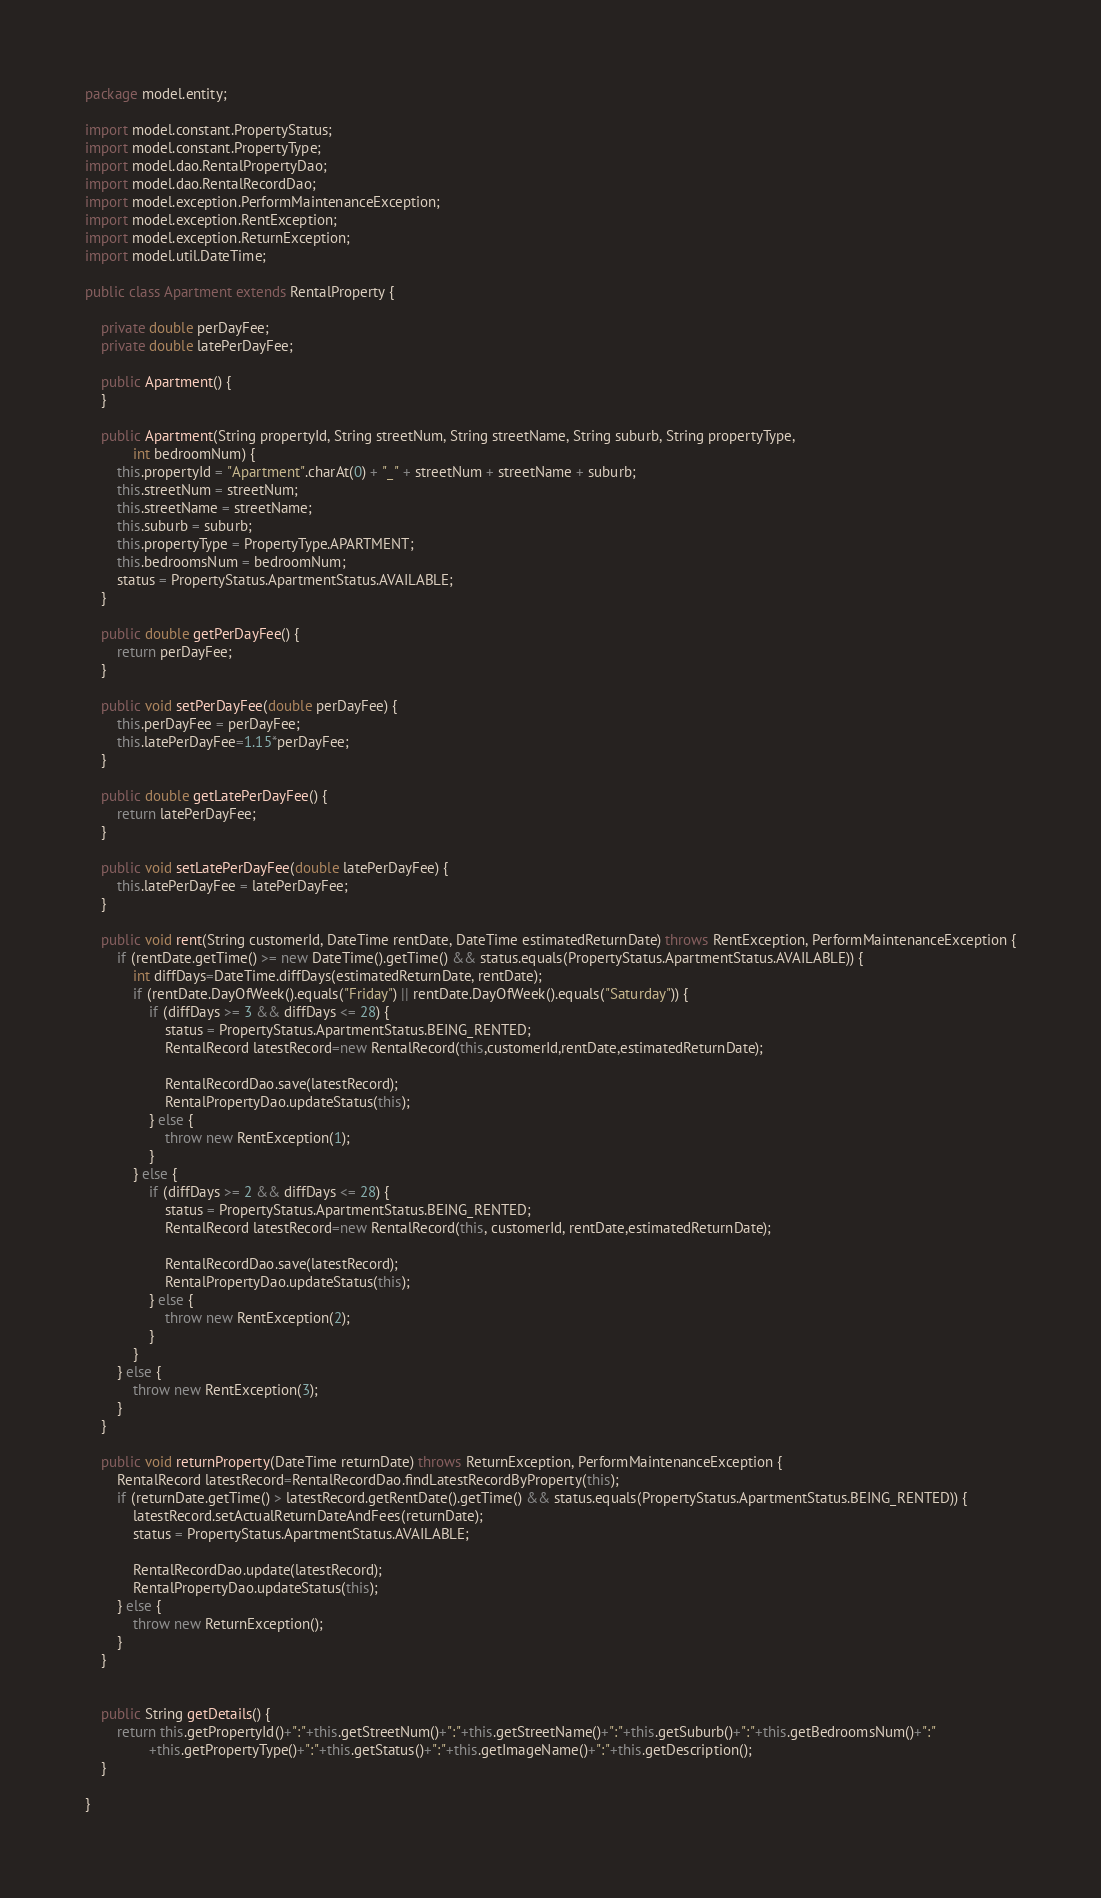Convert code to text. <code><loc_0><loc_0><loc_500><loc_500><_Java_>package model.entity;

import model.constant.PropertyStatus;
import model.constant.PropertyType;
import model.dao.RentalPropertyDao;
import model.dao.RentalRecordDao;
import model.exception.PerformMaintenanceException;
import model.exception.RentException;
import model.exception.ReturnException;
import model.util.DateTime;

public class Apartment extends RentalProperty {

	private double perDayFee;
	private double latePerDayFee;
	
	public Apartment() {
	}

	public Apartment(String propertyId, String streetNum, String streetName, String suburb, String propertyType,
			int bedroomNum) {
		this.propertyId = "Apartment".charAt(0) + "_" + streetNum + streetName + suburb;
		this.streetNum = streetNum;
		this.streetName = streetName;
		this.suburb = suburb;
		this.propertyType = PropertyType.APARTMENT;
		this.bedroomsNum = bedroomNum;
		status = PropertyStatus.ApartmentStatus.AVAILABLE;
	}

	public double getPerDayFee() {
		return perDayFee;
	}

	public void setPerDayFee(double perDayFee) {
		this.perDayFee = perDayFee;
		this.latePerDayFee=1.15*perDayFee;
	}

	public double getLatePerDayFee() {
		return latePerDayFee;
	}

	public void setLatePerDayFee(double latePerDayFee) {
		this.latePerDayFee = latePerDayFee;
	}

	public void rent(String customerId, DateTime rentDate, DateTime estimatedReturnDate) throws RentException, PerformMaintenanceException {
		if (rentDate.getTime() >= new DateTime().getTime() && status.equals(PropertyStatus.ApartmentStatus.AVAILABLE)) {
			int diffDays=DateTime.diffDays(estimatedReturnDate, rentDate);
			if (rentDate.DayOfWeek().equals("Friday") || rentDate.DayOfWeek().equals("Saturday")) {
				if (diffDays >= 3 && diffDays <= 28) {
					status = PropertyStatus.ApartmentStatus.BEING_RENTED;
					RentalRecord latestRecord=new RentalRecord(this,customerId,rentDate,estimatedReturnDate);
					
					RentalRecordDao.save(latestRecord);
					RentalPropertyDao.updateStatus(this);
				} else {
					throw new RentException(1);
				}
			} else {
				if (diffDays >= 2 && diffDays <= 28) {
					status = PropertyStatus.ApartmentStatus.BEING_RENTED;
					RentalRecord latestRecord=new RentalRecord(this, customerId, rentDate,estimatedReturnDate);
					
					RentalRecordDao.save(latestRecord);
					RentalPropertyDao.updateStatus(this);
				} else {
					throw new RentException(2);
				}
			}
		} else {
			throw new RentException(3);
		}
	}

	public void returnProperty(DateTime returnDate) throws ReturnException, PerformMaintenanceException {
		RentalRecord latestRecord=RentalRecordDao.findLatestRecordByProperty(this);
		if (returnDate.getTime() > latestRecord.getRentDate().getTime() && status.equals(PropertyStatus.ApartmentStatus.BEING_RENTED)) {
			latestRecord.setActualReturnDateAndFees(returnDate);
			status = PropertyStatus.ApartmentStatus.AVAILABLE;
			
			RentalRecordDao.update(latestRecord);
			RentalPropertyDao.updateStatus(this);
		} else {
			throw new ReturnException();
		}
	}


	public String getDetails() {
		return this.getPropertyId()+":"+this.getStreetNum()+":"+this.getStreetName()+":"+this.getSuburb()+":"+this.getBedroomsNum()+":"
				+this.getPropertyType()+":"+this.getStatus()+":"+this.getImageName()+":"+this.getDescription();
	}

}
</code> 